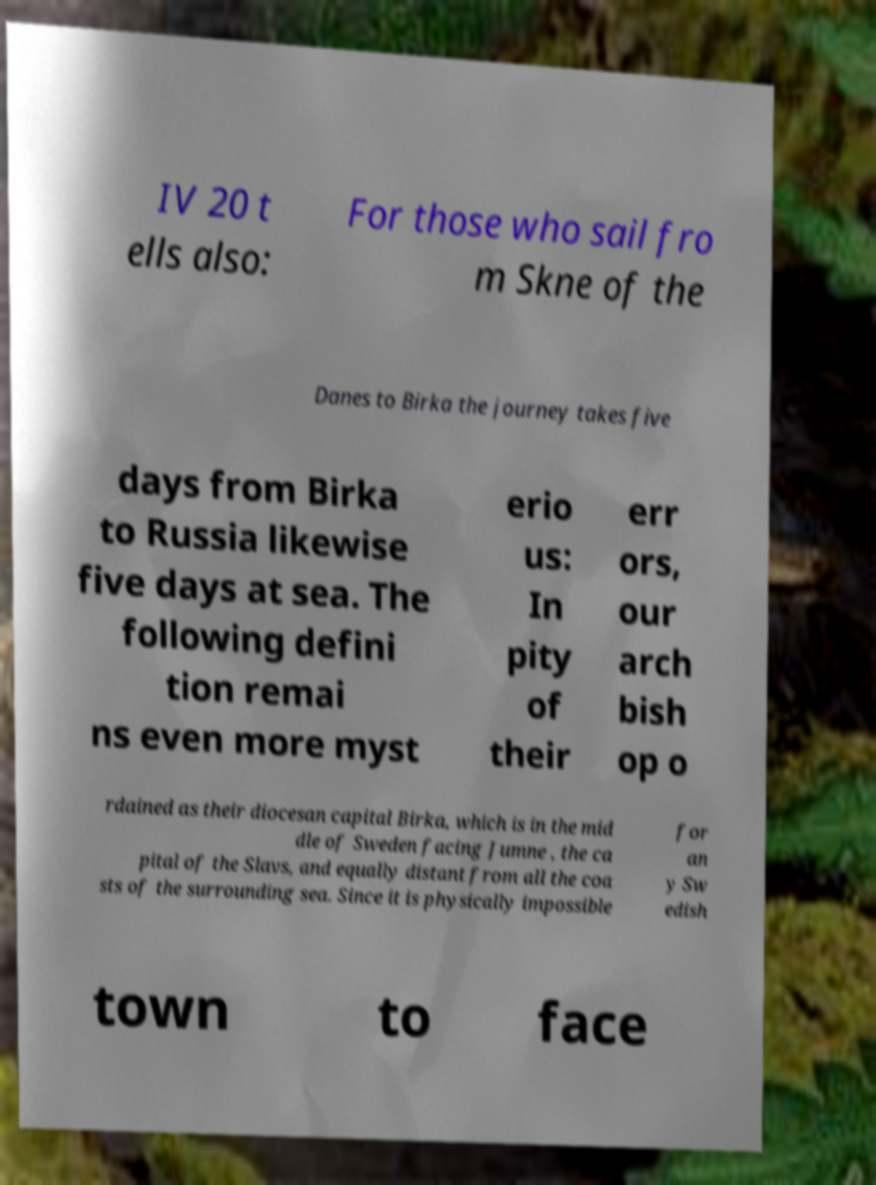Can you read and provide the text displayed in the image?This photo seems to have some interesting text. Can you extract and type it out for me? IV 20 t ells also: For those who sail fro m Skne of the Danes to Birka the journey takes five days from Birka to Russia likewise five days at sea. The following defini tion remai ns even more myst erio us: In pity of their err ors, our arch bish op o rdained as their diocesan capital Birka, which is in the mid dle of Sweden facing Jumne , the ca pital of the Slavs, and equally distant from all the coa sts of the surrounding sea. Since it is physically impossible for an y Sw edish town to face 